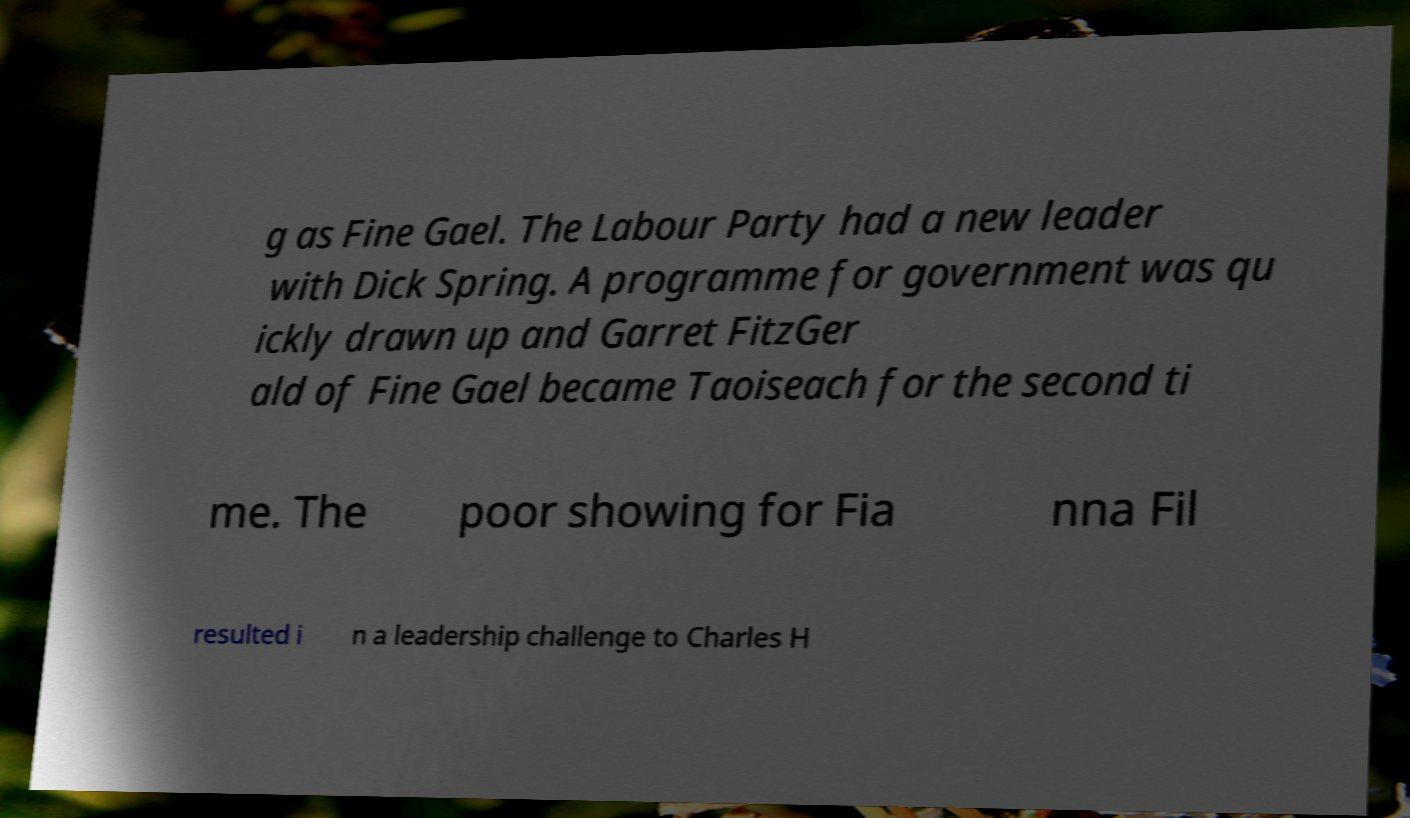I need the written content from this picture converted into text. Can you do that? g as Fine Gael. The Labour Party had a new leader with Dick Spring. A programme for government was qu ickly drawn up and Garret FitzGer ald of Fine Gael became Taoiseach for the second ti me. The poor showing for Fia nna Fil resulted i n a leadership challenge to Charles H 